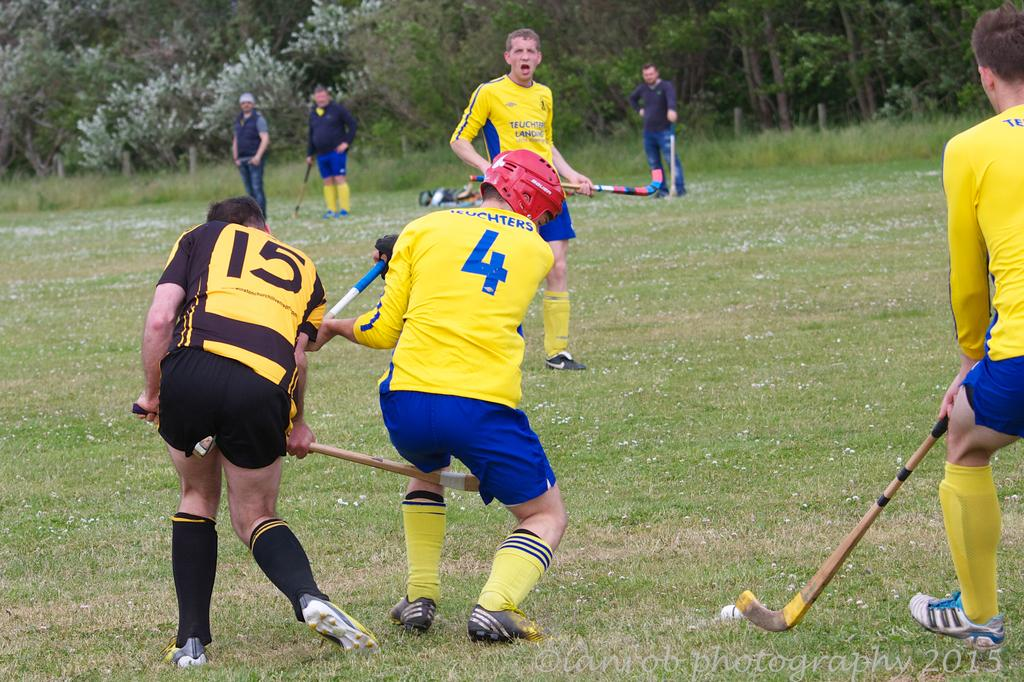<image>
Create a compact narrative representing the image presented. The player wearing black shorts is number 15 